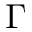Convert formula to latex. <formula><loc_0><loc_0><loc_500><loc_500>\Gamma</formula> 